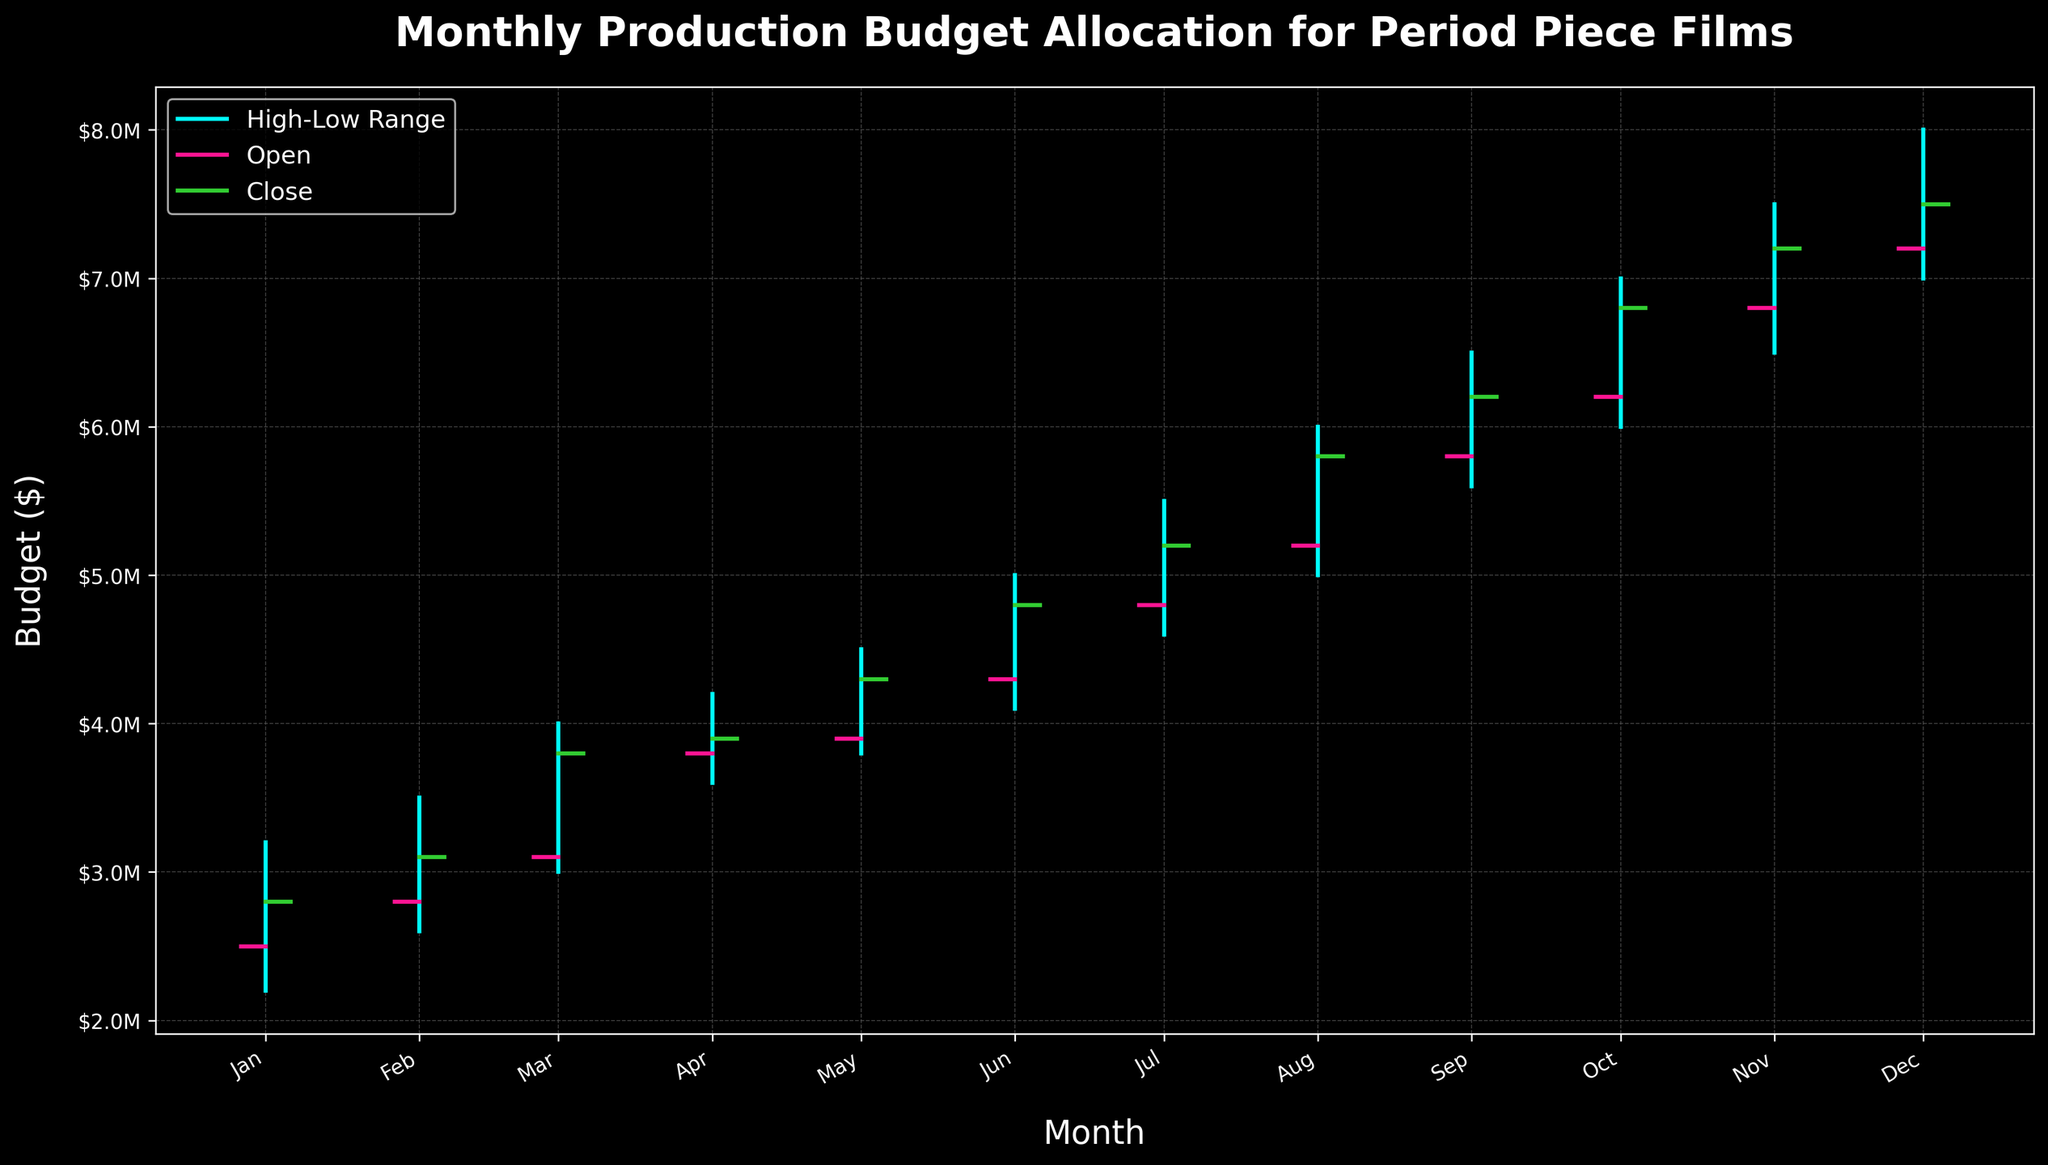What is the title of the chart? The title of the chart is located at the top of the figure. It is written in bold and large font.
Answer: Monthly Production Budget Allocation for Period Piece Films What does the pink line represent in the figure? The legend in the chart explains the color coding. The pink line corresponds to the 'Open' tick.
Answer: Open What was the highest budget allocated in any month? To find the highest budget, look for the maximum value on the y-axis. The highest value touches the top end of the vertical line in December.
Answer: $8M During which month did the closing budget exceed the opening budget the most? To find this, notice the difference between the close (green line) and the open (pink line) for each month. The largest gap occurs in December. The closing budget was $7500000, and the opening budget was $7200000, so the difference is $300000.
Answer: December How many months saw an increase in the closing budget compared to the opening budget? Visually inspect each month's open and close lines. Count the instances where the closing budget (green line) is higher than the opening budget (pink line). There are 11 such months.
Answer: 11 Which month experienced the smallest range in budget allocation? The budget range is the difference between the high and low values for each month. Visually comparing the lengths of the vertical lines, April has the shortest high-low range from $4200000 to $3600000, a difference of $600000.
Answer: April In which month was the opening budget the highest? The highest opening budget can be found by comparing the starting points of the pink lines. December has the highest opening budget at $7200000.
Answer: December What is the difference between the lowest budget value and the highest budget value observed in the chart? The lowest budget value is $2200000 in January, and the highest budget value is $8000000 in December. The difference is $8000000 - $2200000 = $5800000.
Answer: $5800000 Which month saw the highest closing budget? By reviewing the end points of the green lines for each month, December has the highest closing budget, which is $7500000.
Answer: December 